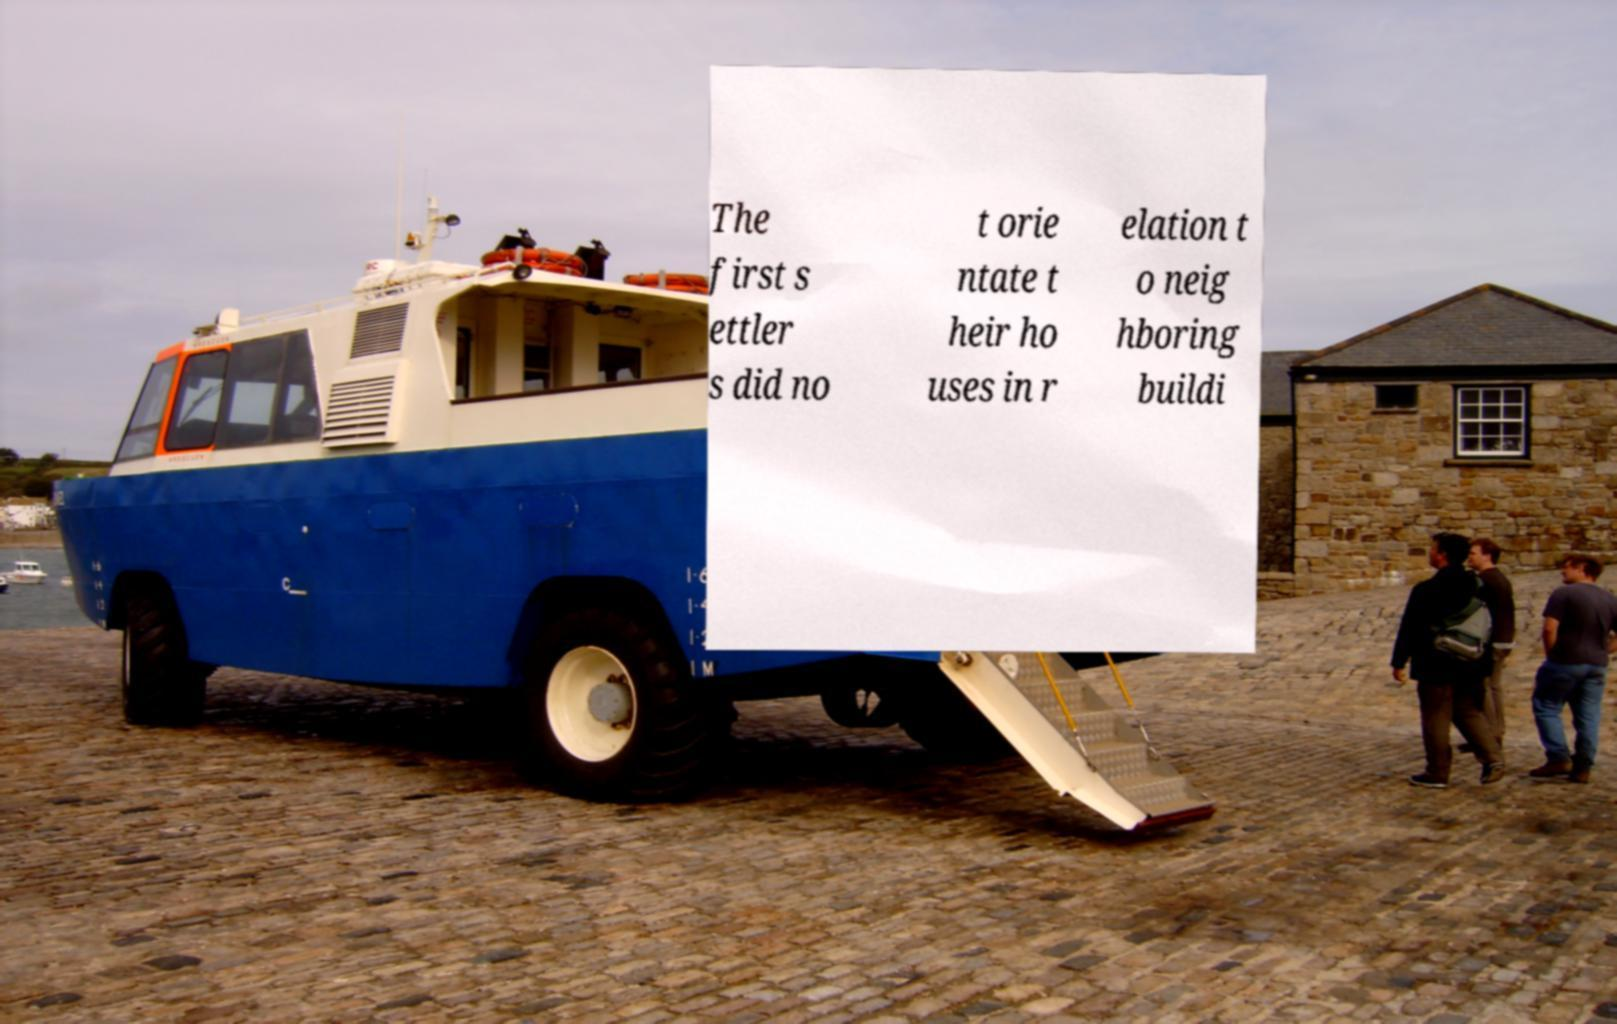What messages or text are displayed in this image? I need them in a readable, typed format. The first s ettler s did no t orie ntate t heir ho uses in r elation t o neig hboring buildi 